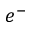<formula> <loc_0><loc_0><loc_500><loc_500>e ^ { - }</formula> 